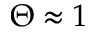Convert formula to latex. <formula><loc_0><loc_0><loc_500><loc_500>\Theta \approx 1</formula> 